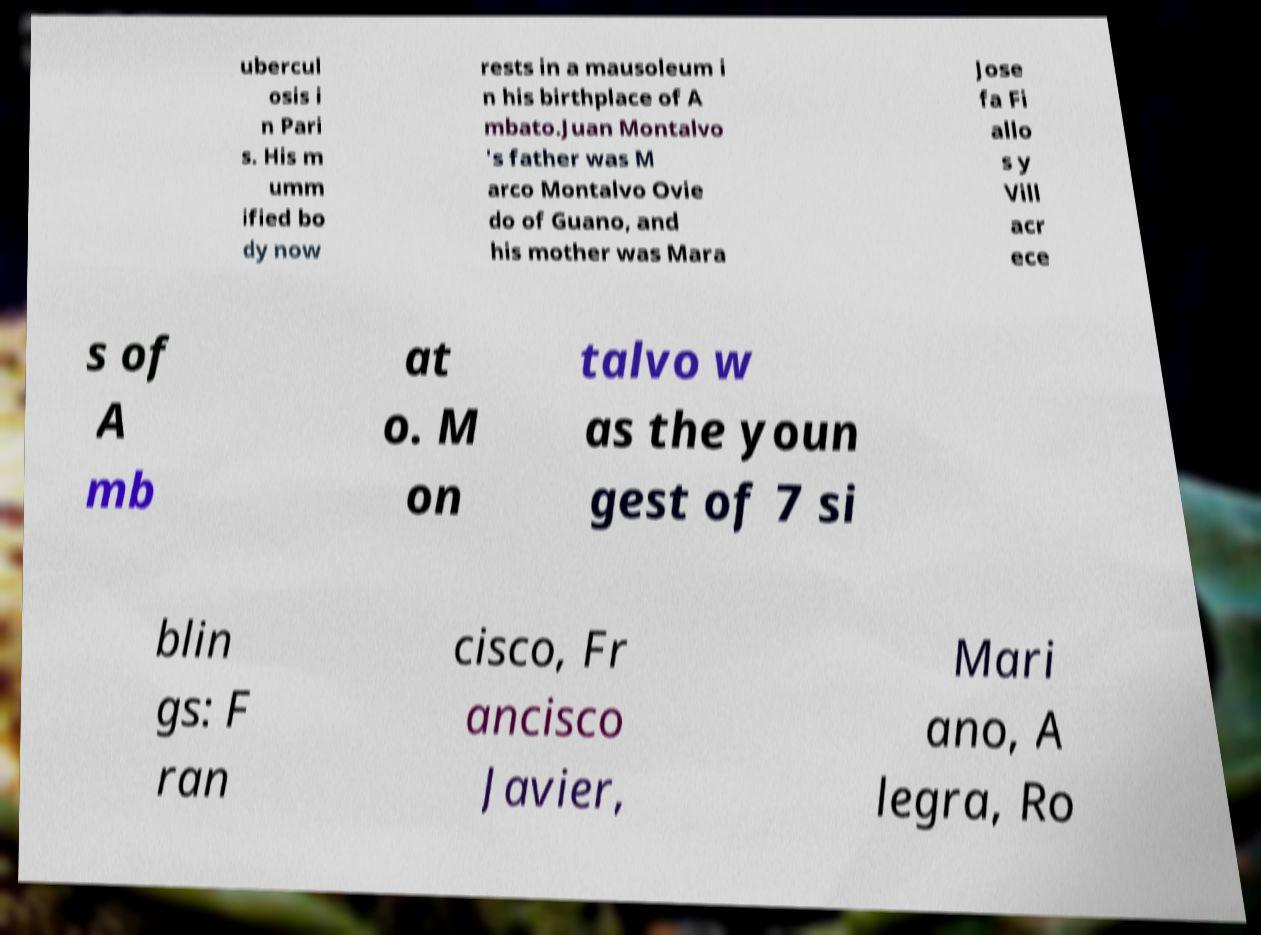What messages or text are displayed in this image? I need them in a readable, typed format. ubercul osis i n Pari s. His m umm ified bo dy now rests in a mausoleum i n his birthplace of A mbato.Juan Montalvo 's father was M arco Montalvo Ovie do of Guano, and his mother was Mara Jose fa Fi allo s y Vill acr ece s of A mb at o. M on talvo w as the youn gest of 7 si blin gs: F ran cisco, Fr ancisco Javier, Mari ano, A legra, Ro 